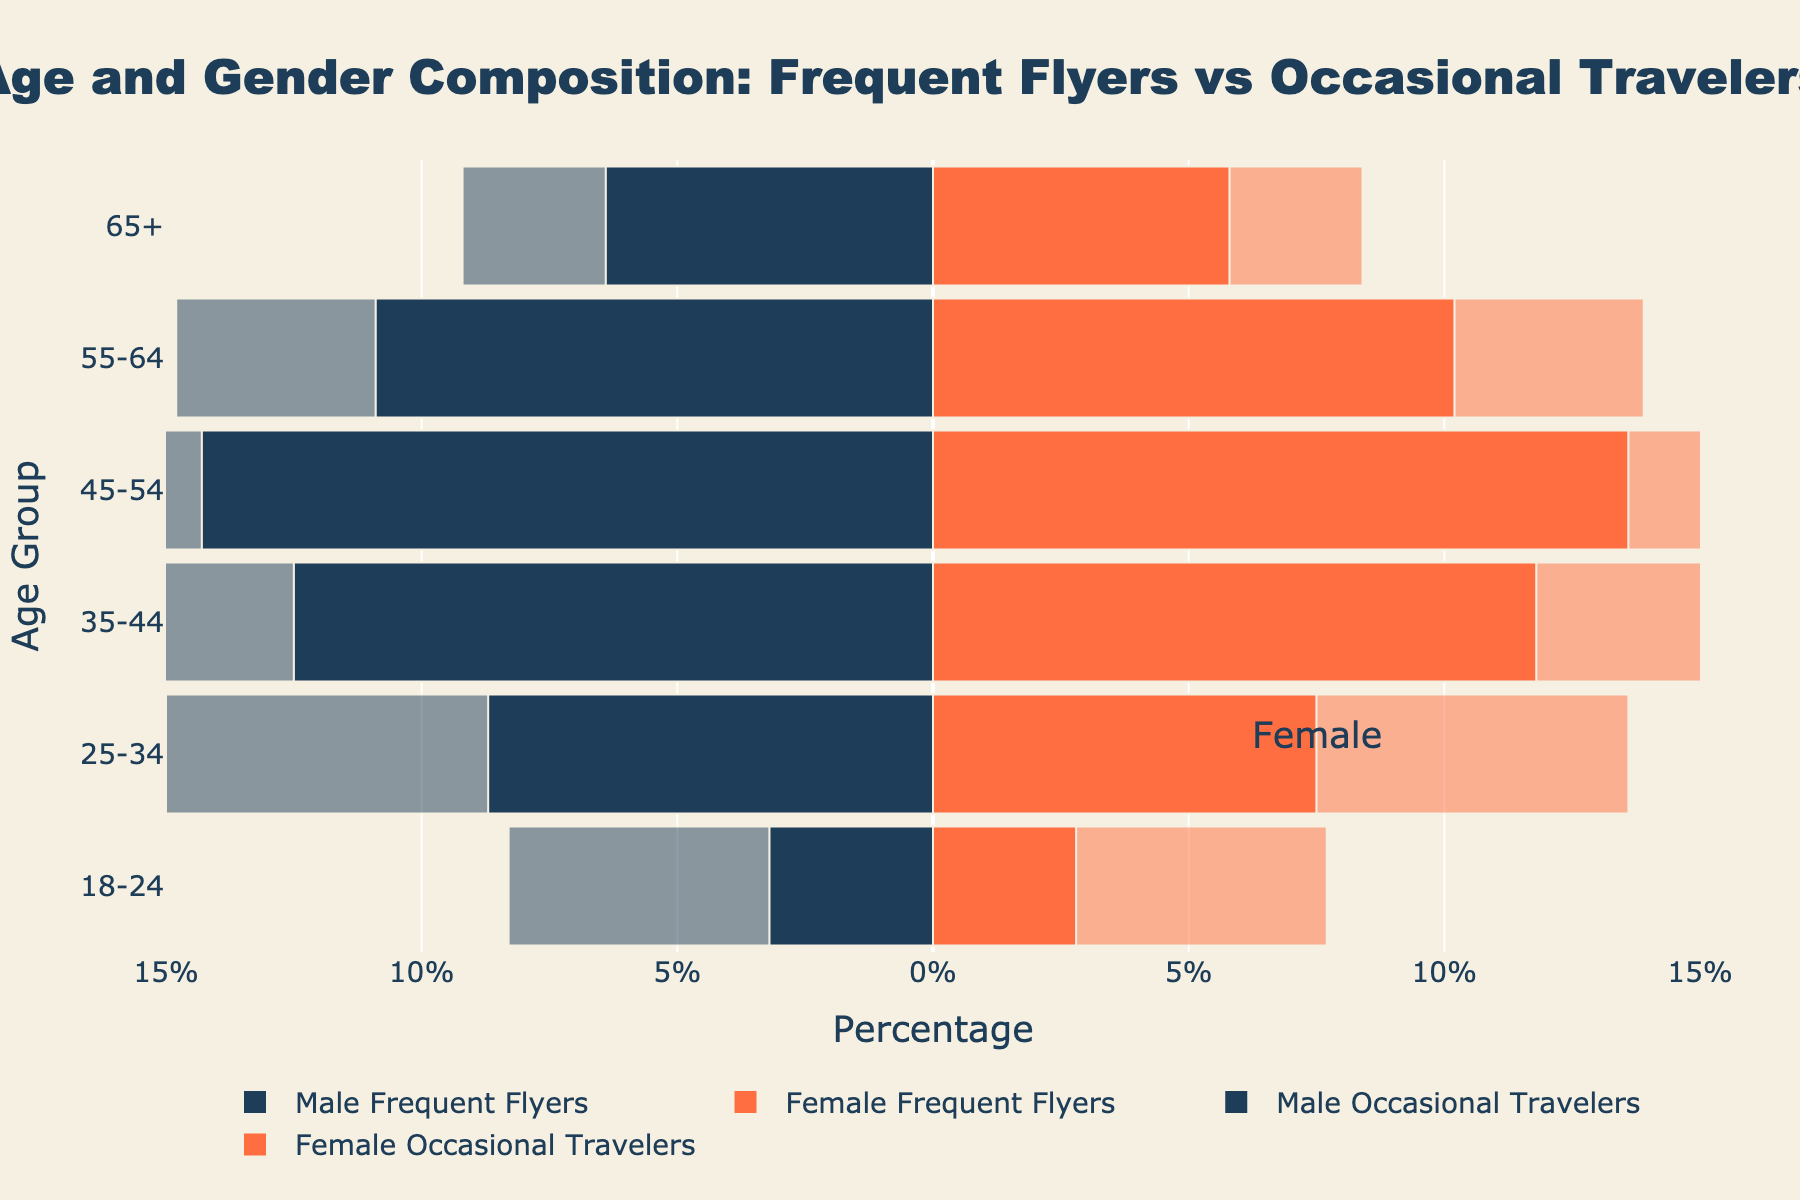What's the title of the plot? The title of the plot is written at the top center of the figure in a bold font. It reads: "Age and Gender Composition: Frequent Flyers vs Occasional Travelers".
Answer: Age and Gender Composition: Frequent Flyers vs Occasional Travelers Which age group has the highest percentage of male frequent flyers? To find the age group with the highest percentage of male frequent flyers, look for the bar extending the farthest to the left in the "Male Frequent Flyers" category. The age group 45-54 has the highest percentage at 14.3%.
Answer: 45-54 What is the total percentage of female frequent flyers aged 35-44 and 45-54? Add the percentage values of "Female Frequent Flyers" for the age groups 35-44 (11.8%) and 45-54 (13.6%). So, 11.8 + 13.6 = 25.4%.
Answer: 25.4% How do male occasional travelers aged 18-24 compare to those aged 55-64? Check the lengths of the bars for "Male Occasional Travelers" in the age groups 18-24 and 55-64. The percentage for age group 18-24 is 5.1%, and for age group 55-64, it is 3.9%. Thus, male occasional travelers aged 18-24 are more frequent than those aged 55-64 by 5.1 - 3.9 = 1.2%.
Answer: 1.2% more Are there more female frequent flyers or female occasional travelers in the 25-34 age group? Compare the lengths of the bars for female frequent flyers and female occasional travelers in the 25-34 age group. Female frequent flyers are at 7.5%, whereas female occasional travelers are at 6.1%. Therefore, there are more female frequent flyers.
Answer: Female frequent flyers What is the difference in the percentage of male frequent flyers and male occasional travelers in the 45-54 age group? Subtract the percentage of male occasional travelers from male frequent flyers for the 45-54 age group. The values are 14.3% (male frequent flyers) and 4.8% (male occasional travelers), so the difference is 14.3 - 4.8 = 9.5%.
Answer: 9.5% Which gender has a higher percentage of frequent flyers aged 55-64? Compare the rightward (female) and leftward (male) bars for frequent flyers in the 55-64 age group. The values are 10.2% for females and 10.9% for males. Thus, males have a slightly higher percentage.
Answer: Males What is the total percentage of frequent flyers (both genders) for the age group 65+? Add the percentage values of "Male Frequent Flyers" and "Female Frequent Flyers" for the age group 65+. The values are 6.4% (male) and 5.8% (female). So, 6.4 + 5.8 = 12.2%.
Answer: 12.2% 